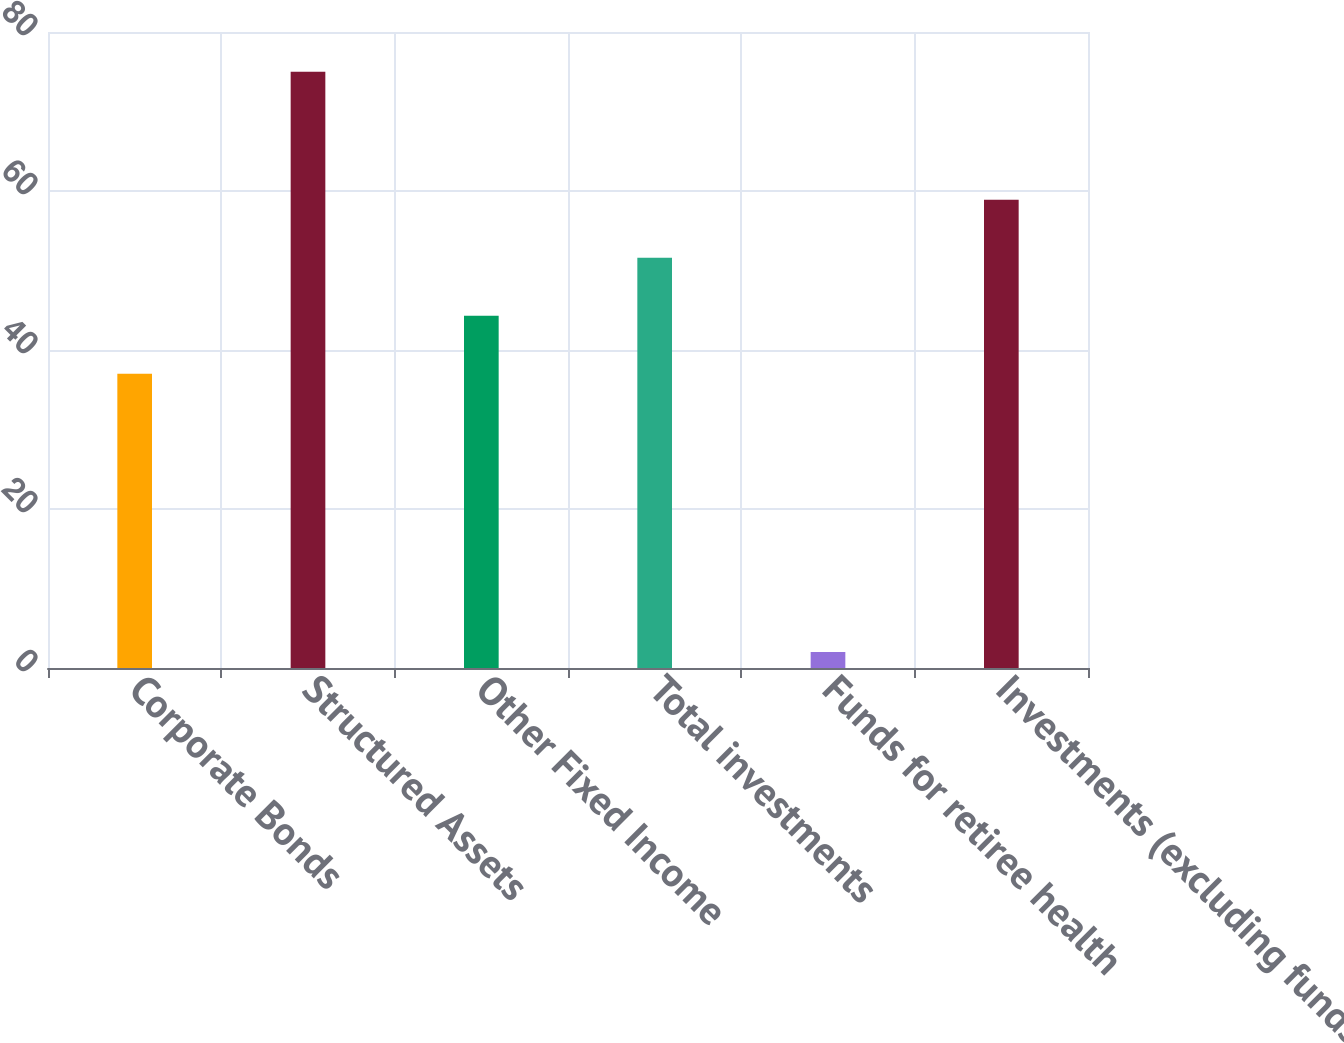Convert chart. <chart><loc_0><loc_0><loc_500><loc_500><bar_chart><fcel>Corporate Bonds<fcel>Structured Assets<fcel>Other Fixed Income<fcel>Total investments<fcel>Funds for retiree health<fcel>Investments (excluding funds<nl><fcel>37<fcel>75<fcel>44.3<fcel>51.6<fcel>2<fcel>58.9<nl></chart> 